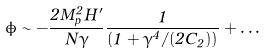Convert formula to latex. <formula><loc_0><loc_0><loc_500><loc_500>\dot { \phi } \sim - \frac { 2 M _ { p } ^ { 2 } H ^ { \prime } } { N \gamma } \frac { 1 } { ( 1 + \gamma ^ { 4 } / ( 2 C _ { 2 } ) ) } + \dots</formula> 